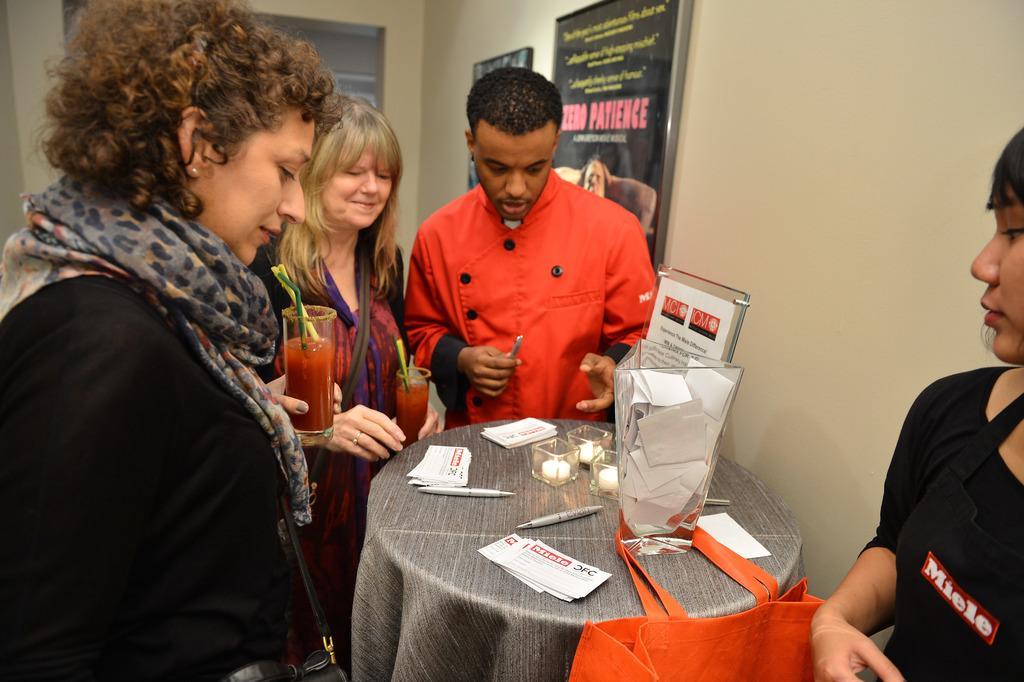Describe this image in one or two sentences. In this image there are four people. In the left side of the image there is a woman standing and looking at table. In the right side of the image a girl is standing. In the middle of the image there is a table on which papers, pens, candles and candle holders are present. At the background there are two boards with a text on it which were hanged to a wall and two persons are standing holding a juice glass. 